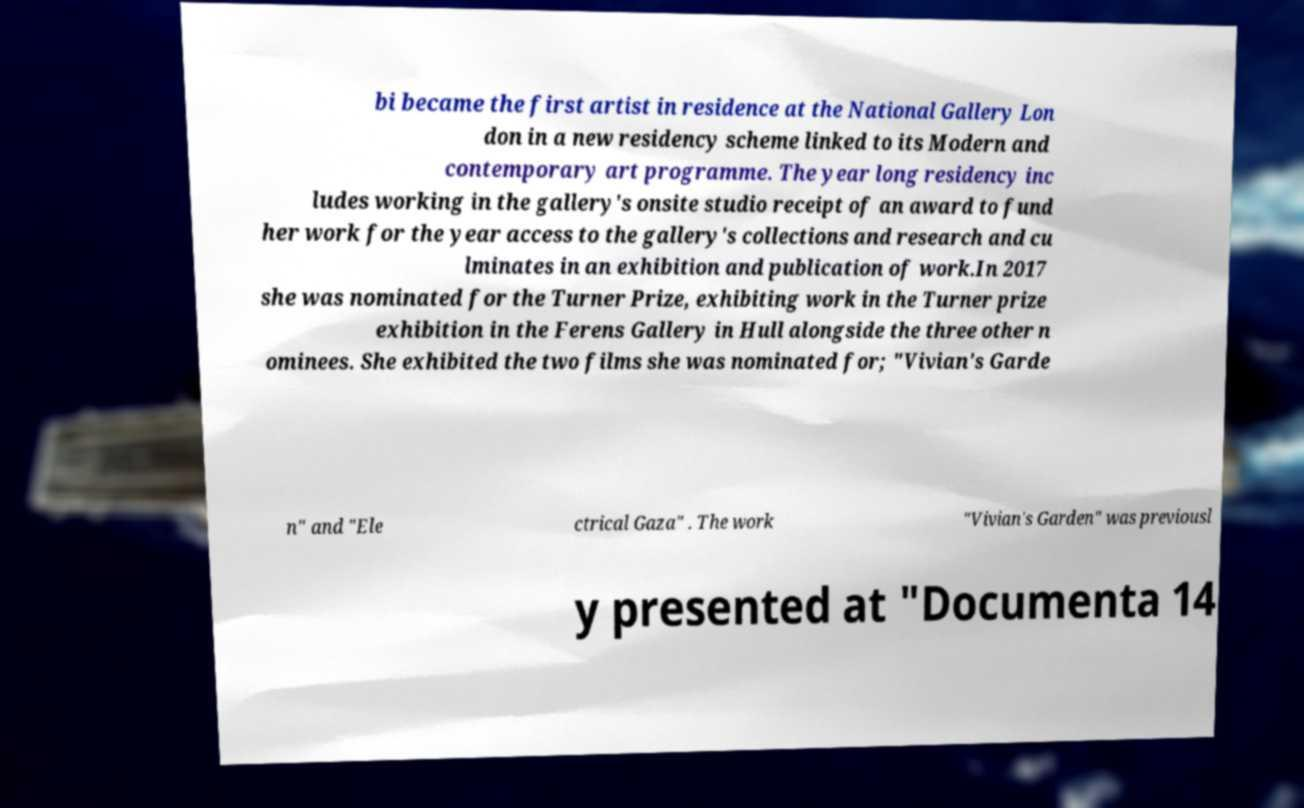I need the written content from this picture converted into text. Can you do that? bi became the first artist in residence at the National Gallery Lon don in a new residency scheme linked to its Modern and contemporary art programme. The year long residency inc ludes working in the gallery's onsite studio receipt of an award to fund her work for the year access to the gallery's collections and research and cu lminates in an exhibition and publication of work.In 2017 she was nominated for the Turner Prize, exhibiting work in the Turner prize exhibition in the Ferens Gallery in Hull alongside the three other n ominees. She exhibited the two films she was nominated for; "Vivian's Garde n" and "Ele ctrical Gaza" . The work "Vivian's Garden" was previousl y presented at "Documenta 14 